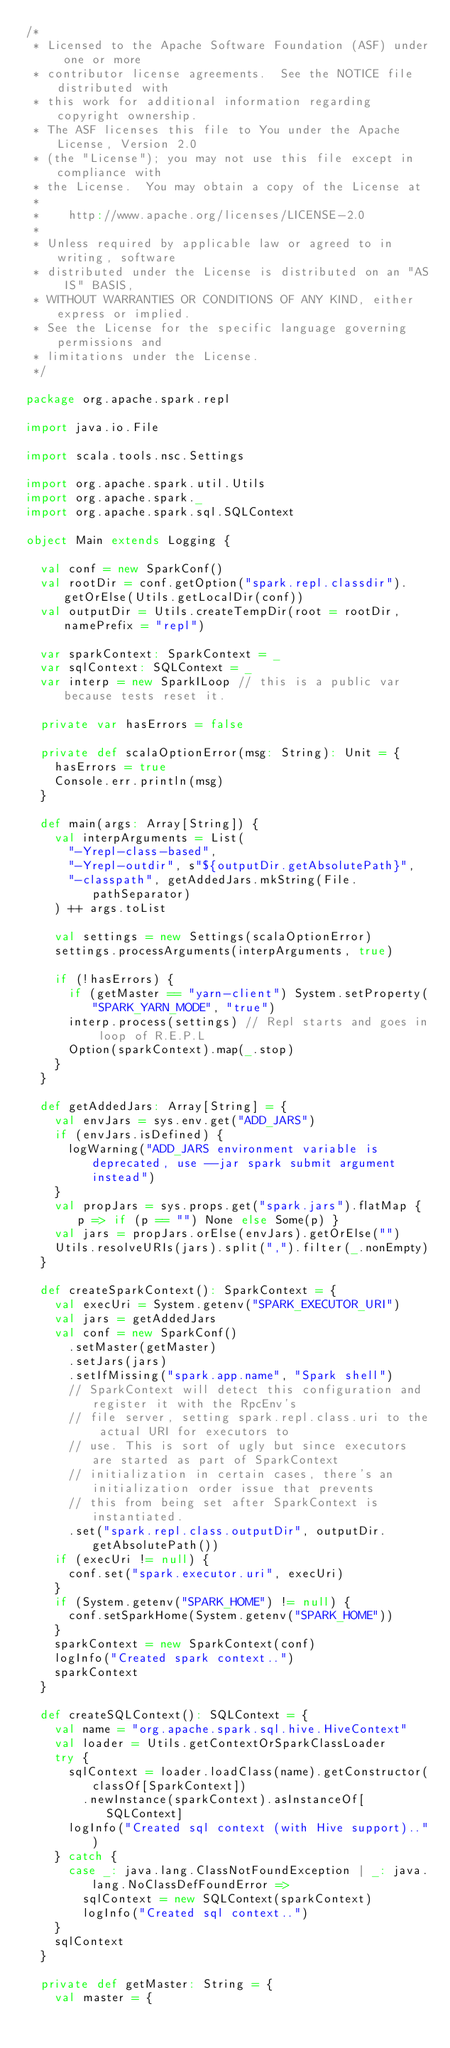<code> <loc_0><loc_0><loc_500><loc_500><_Scala_>/*
 * Licensed to the Apache Software Foundation (ASF) under one or more
 * contributor license agreements.  See the NOTICE file distributed with
 * this work for additional information regarding copyright ownership.
 * The ASF licenses this file to You under the Apache License, Version 2.0
 * (the "License"); you may not use this file except in compliance with
 * the License.  You may obtain a copy of the License at
 *
 *    http://www.apache.org/licenses/LICENSE-2.0
 *
 * Unless required by applicable law or agreed to in writing, software
 * distributed under the License is distributed on an "AS IS" BASIS,
 * WITHOUT WARRANTIES OR CONDITIONS OF ANY KIND, either express or implied.
 * See the License for the specific language governing permissions and
 * limitations under the License.
 */

package org.apache.spark.repl

import java.io.File

import scala.tools.nsc.Settings

import org.apache.spark.util.Utils
import org.apache.spark._
import org.apache.spark.sql.SQLContext

object Main extends Logging {

  val conf = new SparkConf()
  val rootDir = conf.getOption("spark.repl.classdir").getOrElse(Utils.getLocalDir(conf))
  val outputDir = Utils.createTempDir(root = rootDir, namePrefix = "repl")

  var sparkContext: SparkContext = _
  var sqlContext: SQLContext = _
  var interp = new SparkILoop // this is a public var because tests reset it.

  private var hasErrors = false

  private def scalaOptionError(msg: String): Unit = {
    hasErrors = true
    Console.err.println(msg)
  }

  def main(args: Array[String]) {
    val interpArguments = List(
      "-Yrepl-class-based",
      "-Yrepl-outdir", s"${outputDir.getAbsolutePath}",
      "-classpath", getAddedJars.mkString(File.pathSeparator)
    ) ++ args.toList

    val settings = new Settings(scalaOptionError)
    settings.processArguments(interpArguments, true)

    if (!hasErrors) {
      if (getMaster == "yarn-client") System.setProperty("SPARK_YARN_MODE", "true")
      interp.process(settings) // Repl starts and goes in loop of R.E.P.L
      Option(sparkContext).map(_.stop)
    }
  }

  def getAddedJars: Array[String] = {
    val envJars = sys.env.get("ADD_JARS")
    if (envJars.isDefined) {
      logWarning("ADD_JARS environment variable is deprecated, use --jar spark submit argument instead")
    }
    val propJars = sys.props.get("spark.jars").flatMap { p => if (p == "") None else Some(p) }
    val jars = propJars.orElse(envJars).getOrElse("")
    Utils.resolveURIs(jars).split(",").filter(_.nonEmpty)
  }

  def createSparkContext(): SparkContext = {
    val execUri = System.getenv("SPARK_EXECUTOR_URI")
    val jars = getAddedJars
    val conf = new SparkConf()
      .setMaster(getMaster)
      .setJars(jars)
      .setIfMissing("spark.app.name", "Spark shell")
      // SparkContext will detect this configuration and register it with the RpcEnv's
      // file server, setting spark.repl.class.uri to the actual URI for executors to
      // use. This is sort of ugly but since executors are started as part of SparkContext
      // initialization in certain cases, there's an initialization order issue that prevents
      // this from being set after SparkContext is instantiated.
      .set("spark.repl.class.outputDir", outputDir.getAbsolutePath())
    if (execUri != null) {
      conf.set("spark.executor.uri", execUri)
    }
    if (System.getenv("SPARK_HOME") != null) {
      conf.setSparkHome(System.getenv("SPARK_HOME"))
    }
    sparkContext = new SparkContext(conf)
    logInfo("Created spark context..")
    sparkContext
  }

  def createSQLContext(): SQLContext = {
    val name = "org.apache.spark.sql.hive.HiveContext"
    val loader = Utils.getContextOrSparkClassLoader
    try {
      sqlContext = loader.loadClass(name).getConstructor(classOf[SparkContext])
        .newInstance(sparkContext).asInstanceOf[SQLContext]
      logInfo("Created sql context (with Hive support)..")
    } catch {
      case _: java.lang.ClassNotFoundException | _: java.lang.NoClassDefFoundError =>
        sqlContext = new SQLContext(sparkContext)
        logInfo("Created sql context..")
    }
    sqlContext
  }

  private def getMaster: String = {
    val master = {</code> 